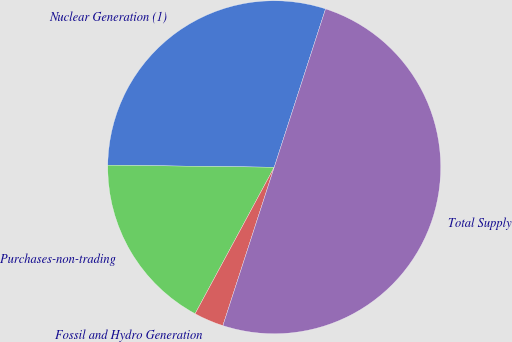<chart> <loc_0><loc_0><loc_500><loc_500><pie_chart><fcel>Nuclear Generation (1)<fcel>Purchases-non-trading<fcel>Fossil and Hydro Generation<fcel>Total Supply<nl><fcel>29.79%<fcel>17.32%<fcel>2.89%<fcel>50.0%<nl></chart> 